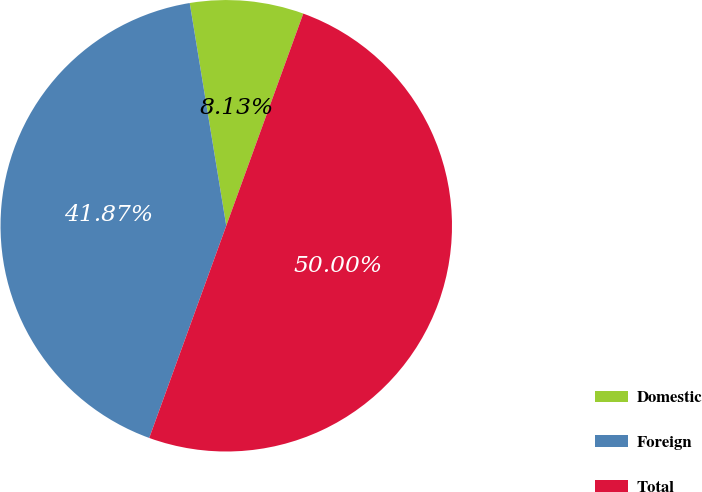Convert chart. <chart><loc_0><loc_0><loc_500><loc_500><pie_chart><fcel>Domestic<fcel>Foreign<fcel>Total<nl><fcel>8.13%<fcel>41.87%<fcel>50.0%<nl></chart> 